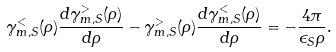<formula> <loc_0><loc_0><loc_500><loc_500>\gamma _ { m , S } ^ { < } ( \rho ) \frac { d \gamma _ { m , S } ^ { > } ( \rho ) } { d \rho } - \gamma _ { m , S } ^ { > } ( \rho ) \frac { d \gamma _ { m , S } ^ { < } ( \rho ) } { d \rho } = - \frac { 4 \pi } { \epsilon _ { S } \rho } .</formula> 